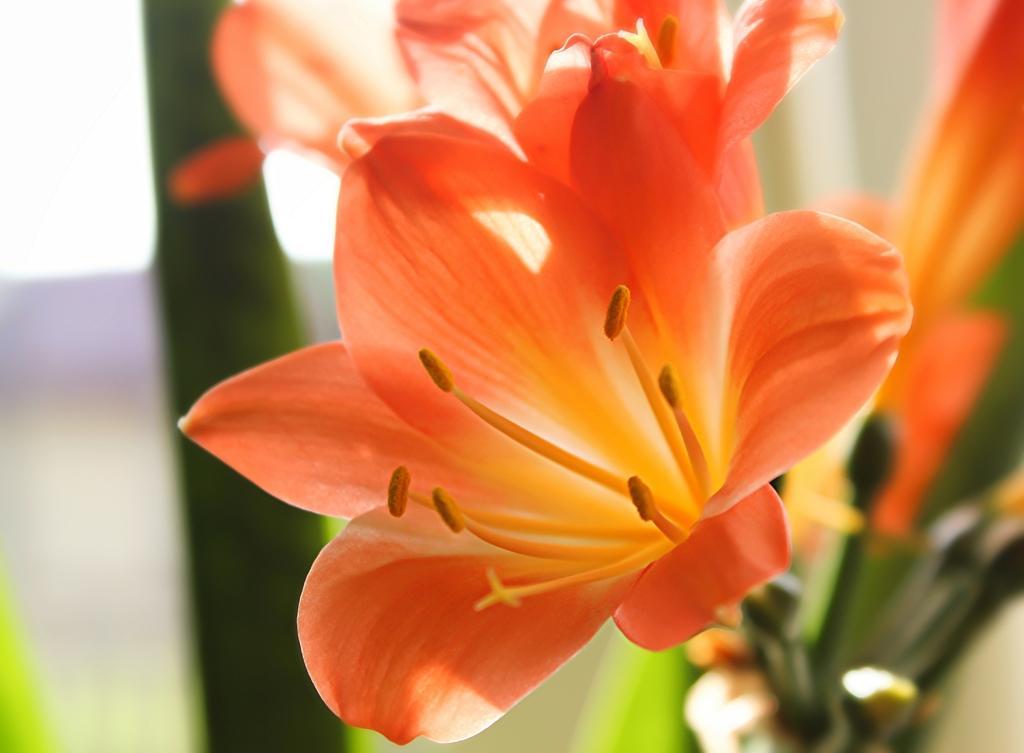In one or two sentences, can you explain what this image depicts? In this image, we can see flowers. Background there is a blur view. 